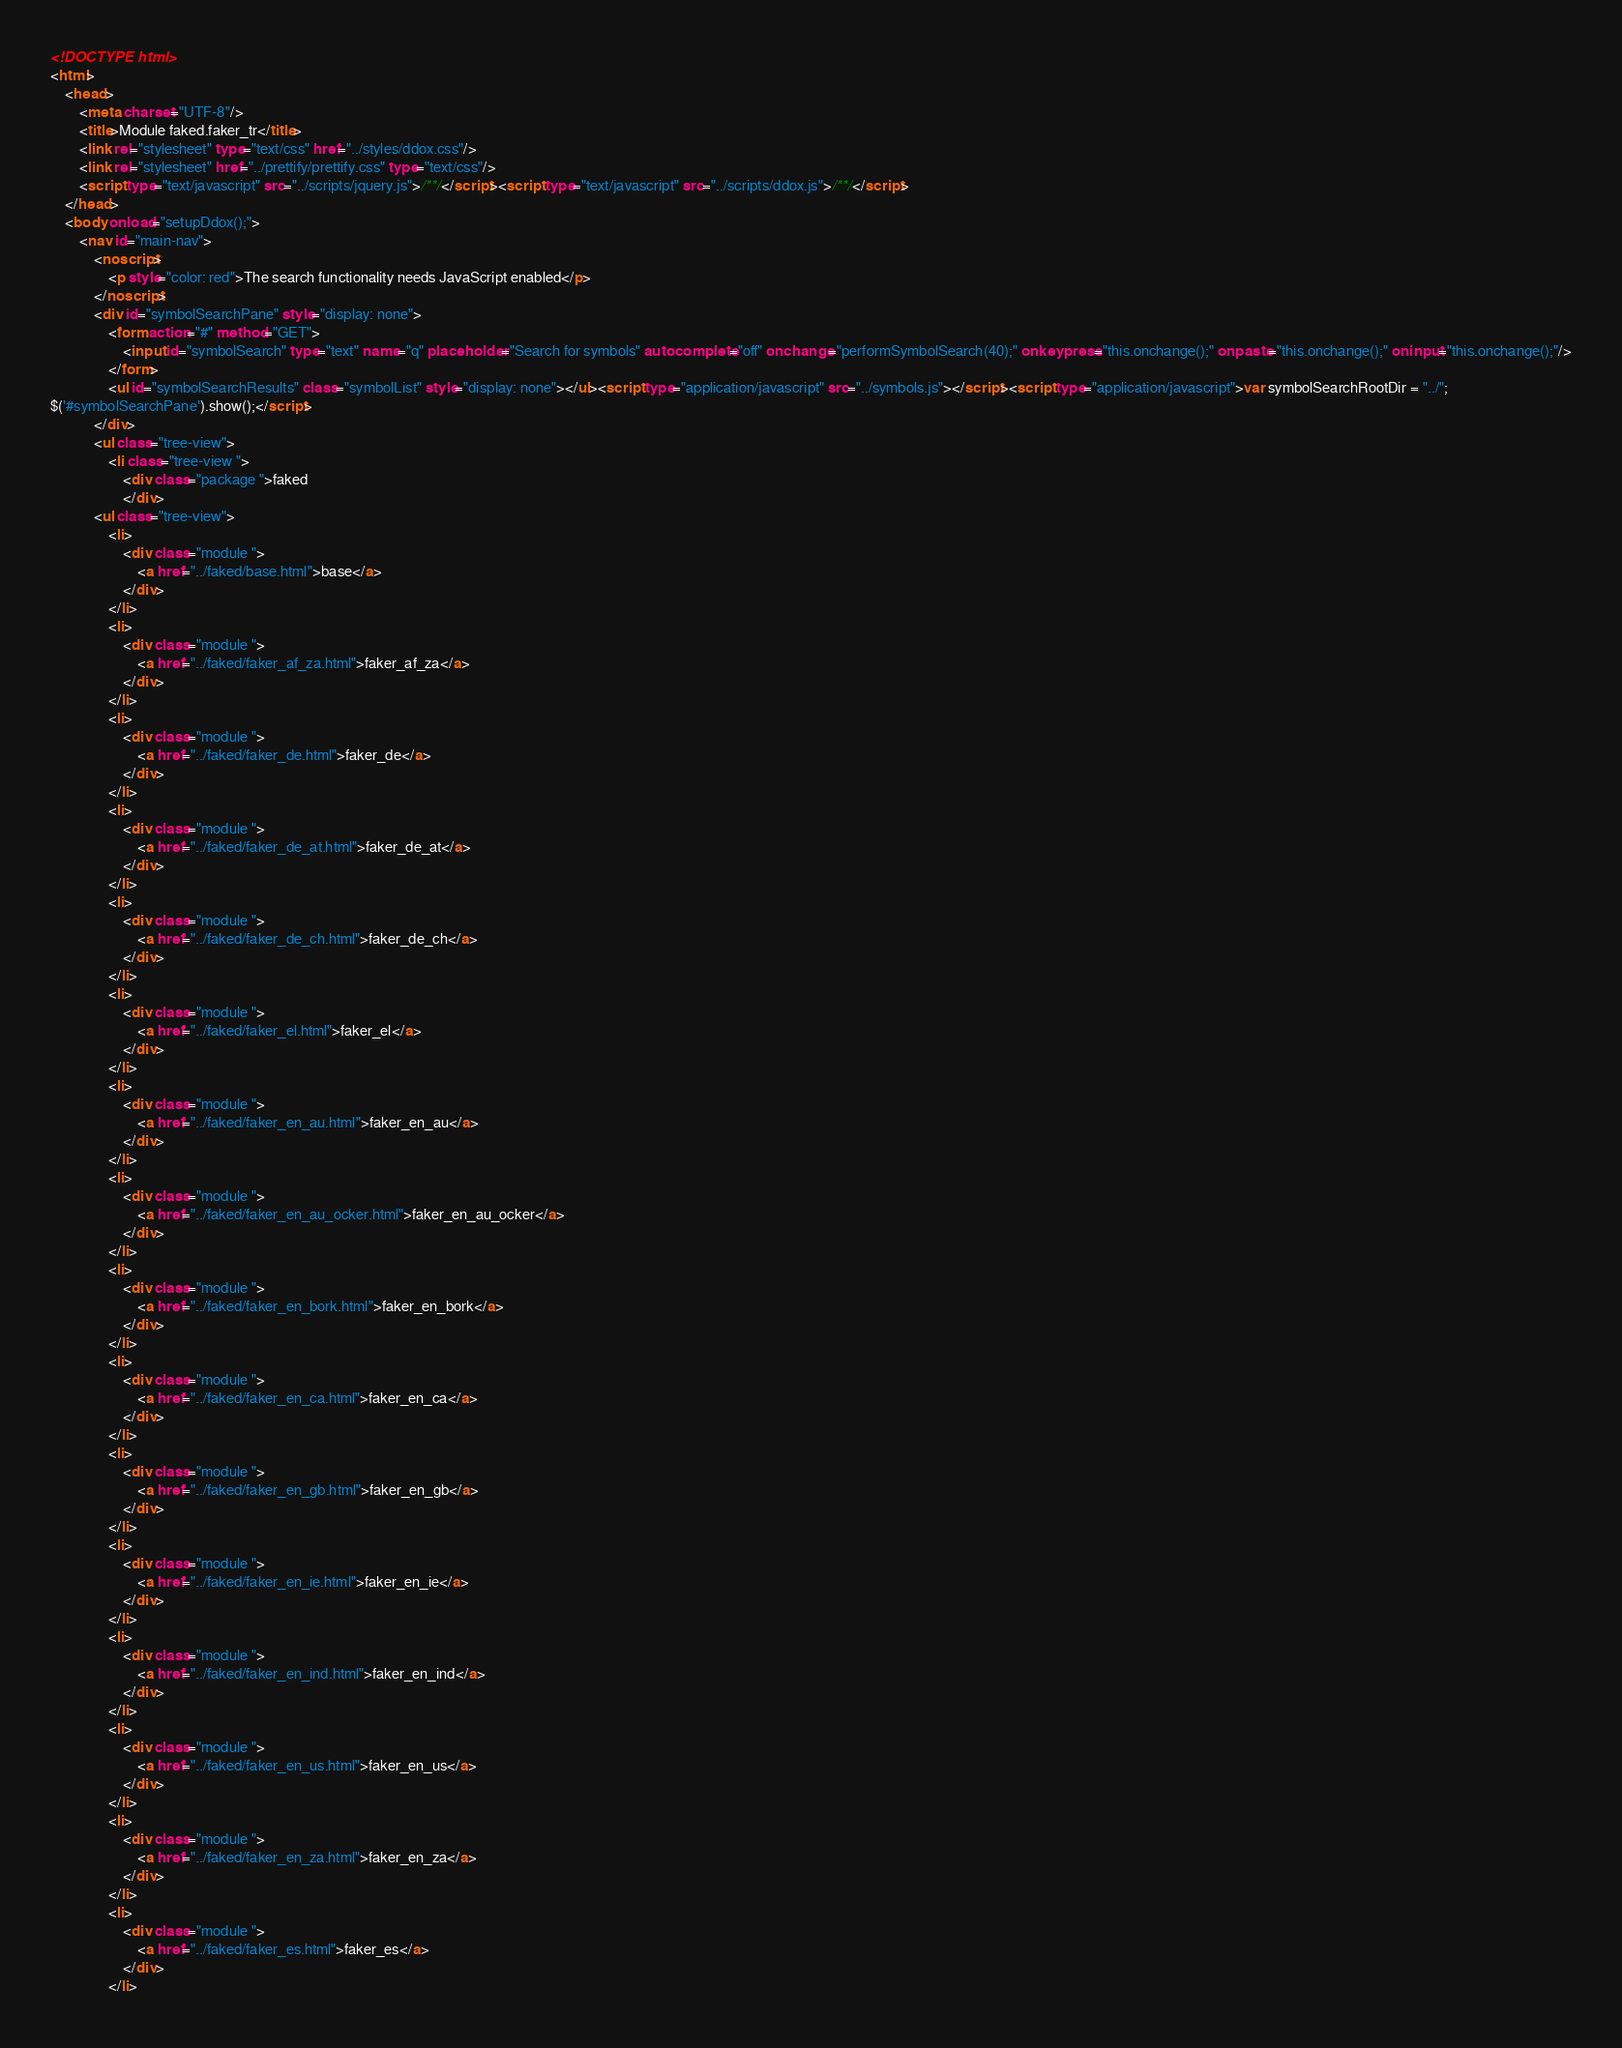<code> <loc_0><loc_0><loc_500><loc_500><_HTML_><!DOCTYPE html>
<html>
	<head>
		<meta charset="UTF-8"/>
		<title>Module faked.faker_tr</title>
		<link rel="stylesheet" type="text/css" href="../styles/ddox.css"/>
		<link rel="stylesheet" href="../prettify/prettify.css" type="text/css"/>
		<script type="text/javascript" src="../scripts/jquery.js">/**/</script><script type="text/javascript" src="../scripts/ddox.js">/**/</script>
	</head>
	<body onload="setupDdox();">
		<nav id="main-nav">
			<noscript>
				<p style="color: red">The search functionality needs JavaScript enabled</p>
			</noscript>
			<div id="symbolSearchPane" style="display: none">
				<form action="#" method="GET">
					<input id="symbolSearch" type="text" name="q" placeholder="Search for symbols" autocomplete="off" onchange="performSymbolSearch(40);" onkeypress="this.onchange();" onpaste="this.onchange();" oninput="this.onchange();"/>
				</form>
				<ul id="symbolSearchResults" class="symbolList" style="display: none"></ul><script type="application/javascript" src="../symbols.js"></script><script type="application/javascript">var symbolSearchRootDir = "../";
$('#symbolSearchPane').show();</script>
			</div>
			<ul class="tree-view">
				<li class="tree-view ">
					<div class="package ">faked
					</div>
			<ul class="tree-view">
				<li>
					<div class="module ">
						<a href="../faked/base.html">base</a>
					</div>
				</li>
				<li>
					<div class="module ">
						<a href="../faked/faker_af_za.html">faker_af_za</a>
					</div>
				</li>
				<li>
					<div class="module ">
						<a href="../faked/faker_de.html">faker_de</a>
					</div>
				</li>
				<li>
					<div class="module ">
						<a href="../faked/faker_de_at.html">faker_de_at</a>
					</div>
				</li>
				<li>
					<div class="module ">
						<a href="../faked/faker_de_ch.html">faker_de_ch</a>
					</div>
				</li>
				<li>
					<div class="module ">
						<a href="../faked/faker_el.html">faker_el</a>
					</div>
				</li>
				<li>
					<div class="module ">
						<a href="../faked/faker_en_au.html">faker_en_au</a>
					</div>
				</li>
				<li>
					<div class="module ">
						<a href="../faked/faker_en_au_ocker.html">faker_en_au_ocker</a>
					</div>
				</li>
				<li>
					<div class="module ">
						<a href="../faked/faker_en_bork.html">faker_en_bork</a>
					</div>
				</li>
				<li>
					<div class="module ">
						<a href="../faked/faker_en_ca.html">faker_en_ca</a>
					</div>
				</li>
				<li>
					<div class="module ">
						<a href="../faked/faker_en_gb.html">faker_en_gb</a>
					</div>
				</li>
				<li>
					<div class="module ">
						<a href="../faked/faker_en_ie.html">faker_en_ie</a>
					</div>
				</li>
				<li>
					<div class="module ">
						<a href="../faked/faker_en_ind.html">faker_en_ind</a>
					</div>
				</li>
				<li>
					<div class="module ">
						<a href="../faked/faker_en_us.html">faker_en_us</a>
					</div>
				</li>
				<li>
					<div class="module ">
						<a href="../faked/faker_en_za.html">faker_en_za</a>
					</div>
				</li>
				<li>
					<div class="module ">
						<a href="../faked/faker_es.html">faker_es</a>
					</div>
				</li></code> 